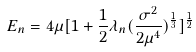Convert formula to latex. <formula><loc_0><loc_0><loc_500><loc_500>E _ { n } = 4 \mu [ 1 + \frac { 1 } { 2 } \lambda _ { n } ( \frac { \sigma ^ { 2 } } { 2 \mu ^ { 4 } } ) ^ { \frac { 1 } { 3 } } ] ^ { \frac { 1 } { 2 } }</formula> 